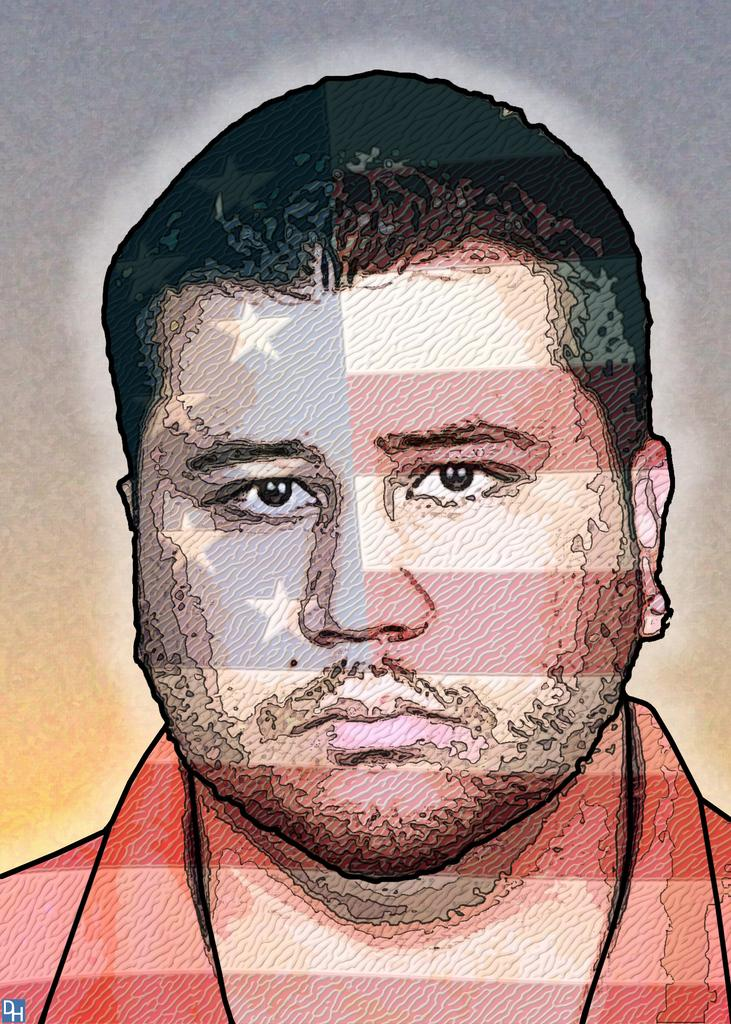What is the main subject of the image? The main subject of the image is a passport size photograph of a man. Has the photograph been altered in any way? Yes, the photograph has been edited. What is the man in the photograph doing? The man is giving a pose to the camera. How is the background of the photograph depicted? The background of the photograph is blurred. What type of pipe can be seen in the photograph? There is no pipe present in the photograph; it features a man in the image. 